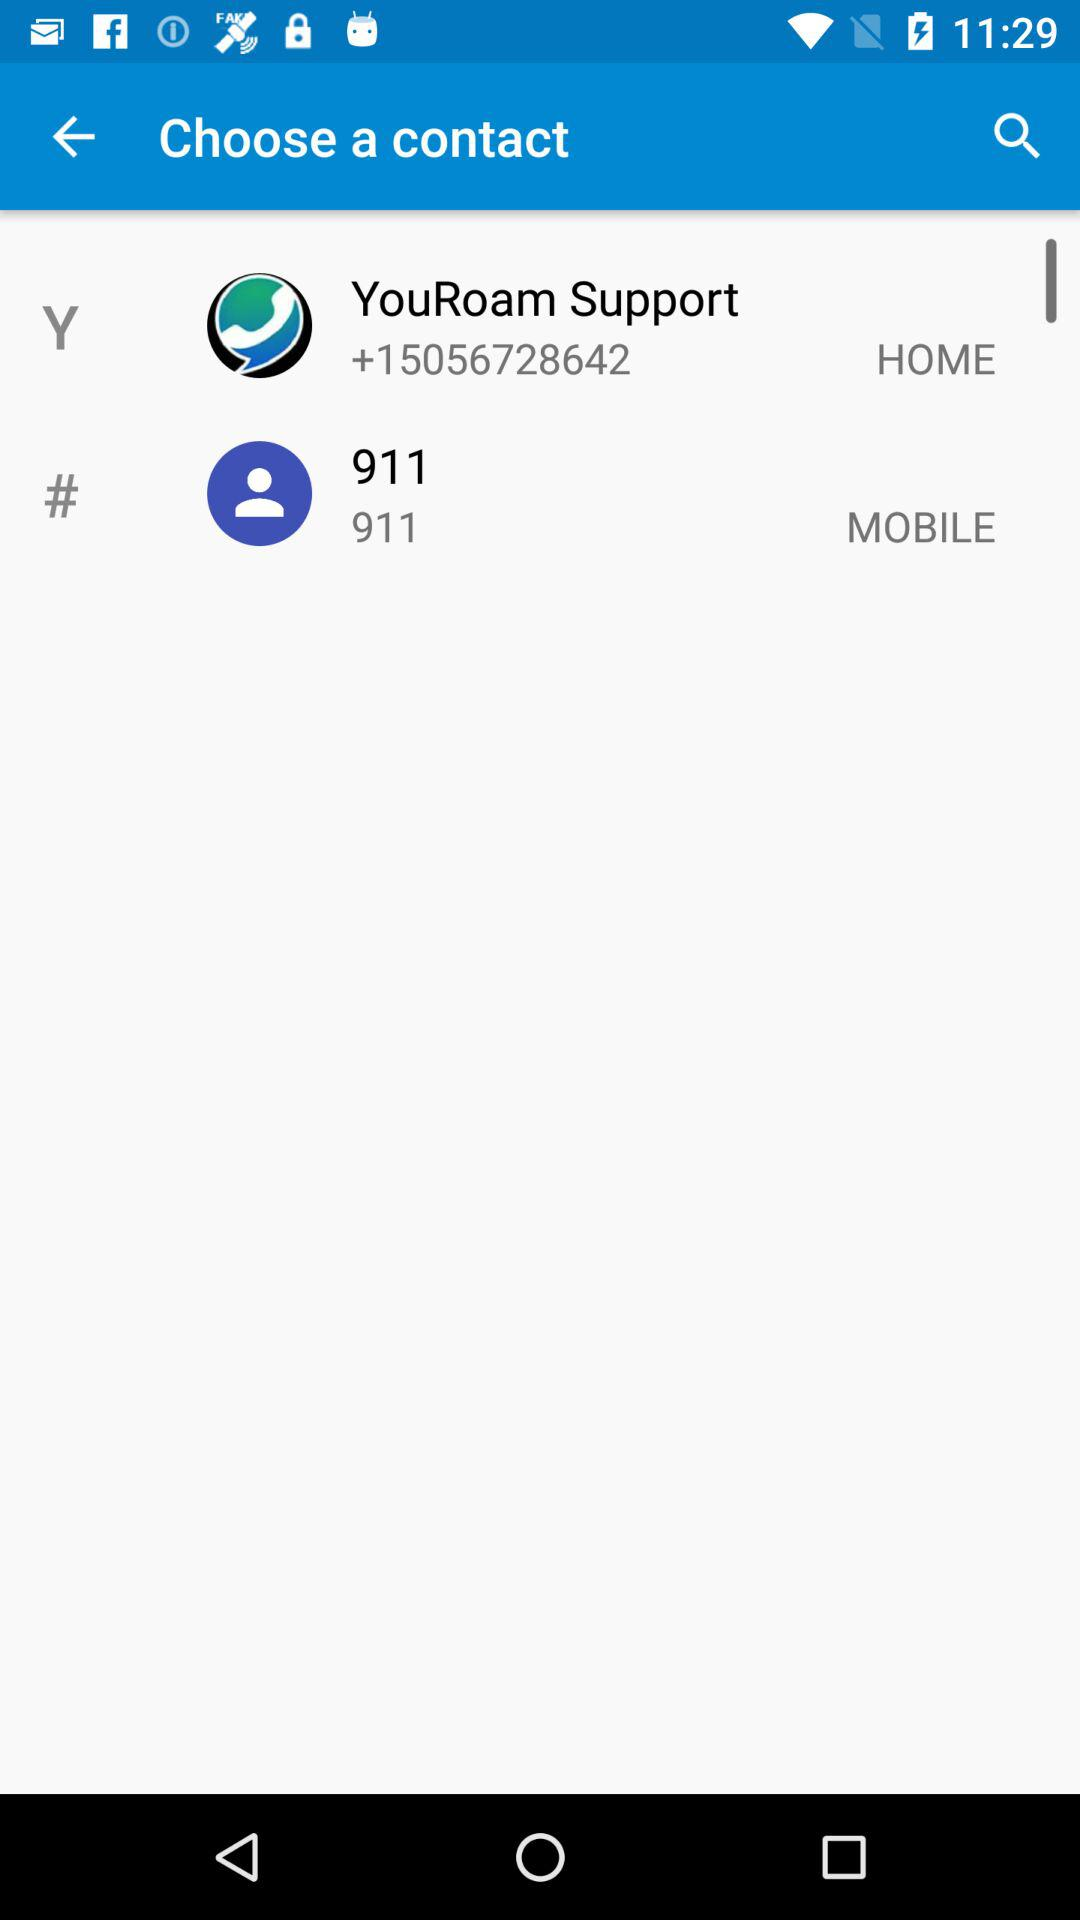How many contacts are there with a phone number?
Answer the question using a single word or phrase. 2 